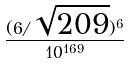Convert formula to latex. <formula><loc_0><loc_0><loc_500><loc_500>\frac { ( 6 / \sqrt { 2 0 9 } ) ^ { 6 } } { 1 0 ^ { 1 6 9 } }</formula> 